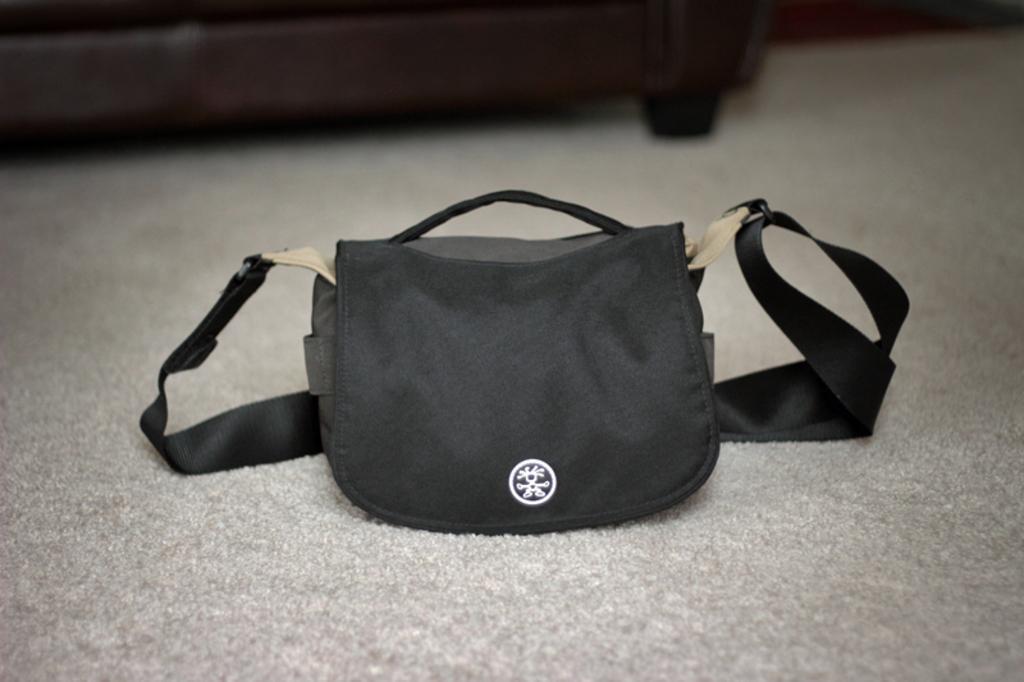How would you summarize this image in a sentence or two? There is a black color bag with black belt. 